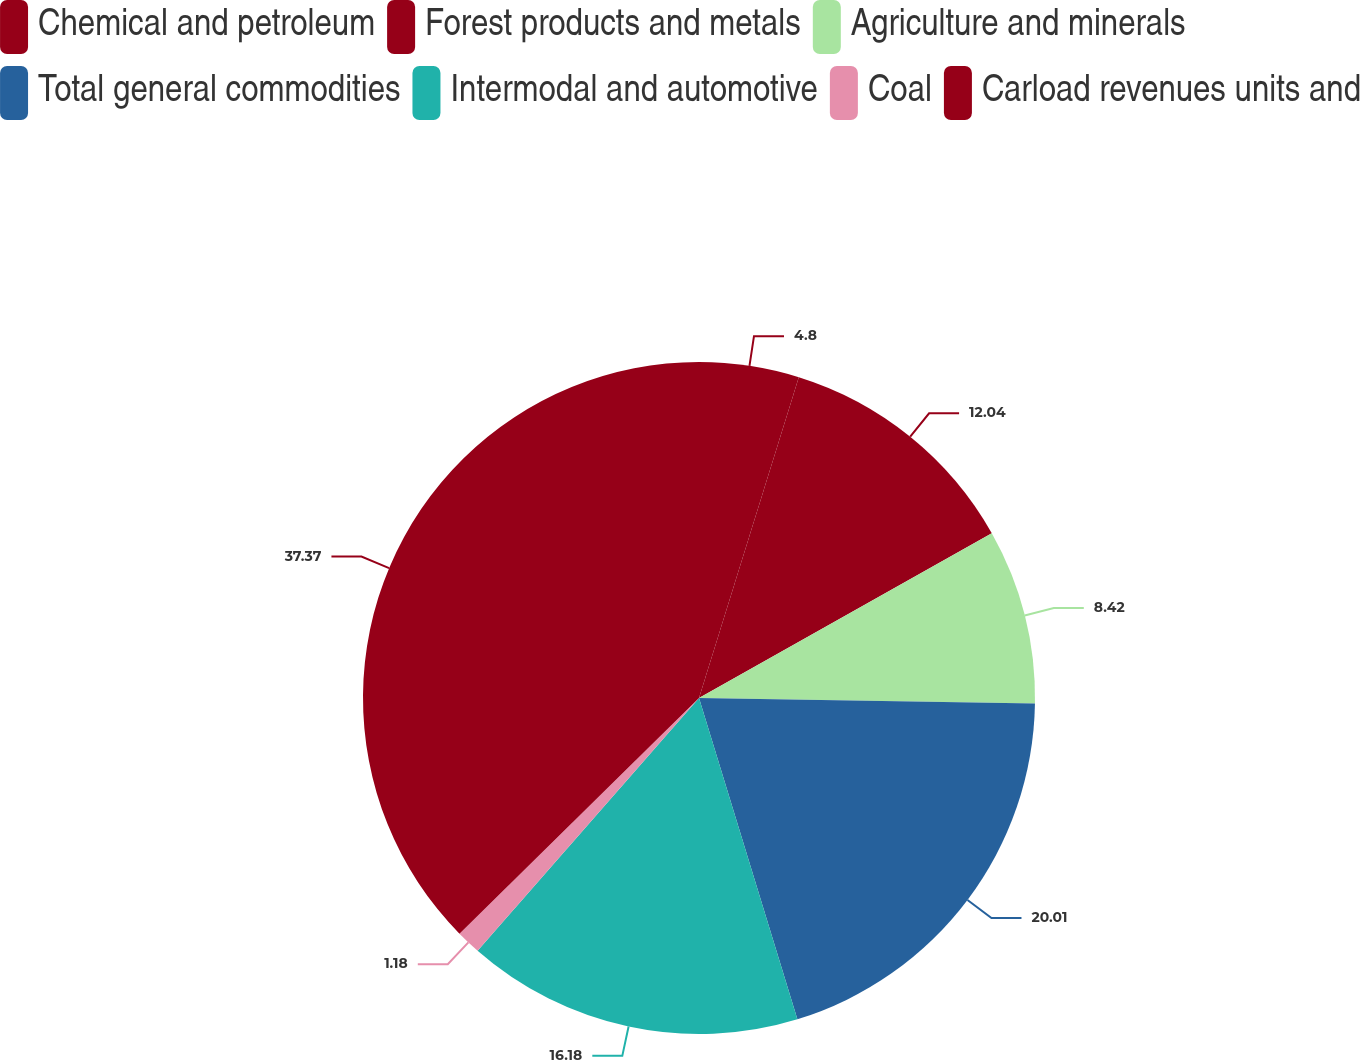<chart> <loc_0><loc_0><loc_500><loc_500><pie_chart><fcel>Chemical and petroleum<fcel>Forest products and metals<fcel>Agriculture and minerals<fcel>Total general commodities<fcel>Intermodal and automotive<fcel>Coal<fcel>Carload revenues units and<nl><fcel>4.8%<fcel>12.04%<fcel>8.42%<fcel>20.01%<fcel>16.18%<fcel>1.18%<fcel>37.37%<nl></chart> 